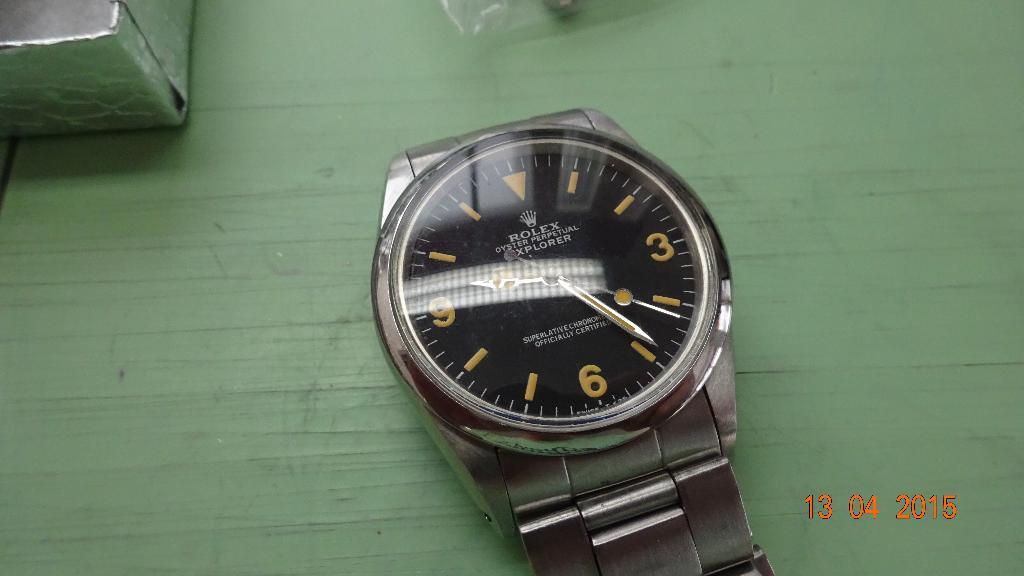This is watch?
Make the answer very short. Yes. What time of the watch?
Provide a short and direct response. 9:24. 